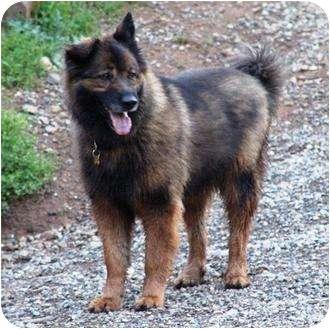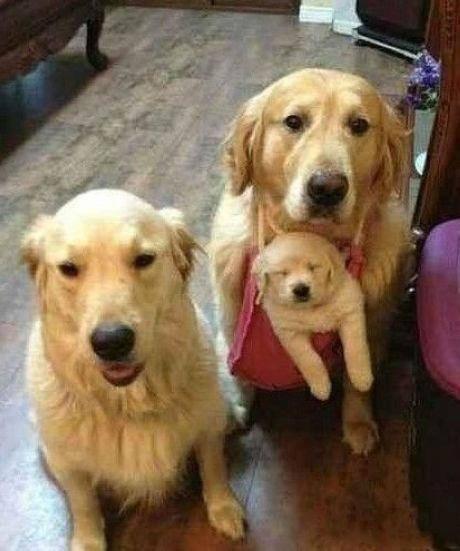The first image is the image on the left, the second image is the image on the right. Assess this claim about the two images: "In one image a dog is lying down on a raised surface.". Correct or not? Answer yes or no. No. The first image is the image on the left, the second image is the image on the right. Analyze the images presented: Is the assertion "At least one of the dogs is indoors." valid? Answer yes or no. Yes. 